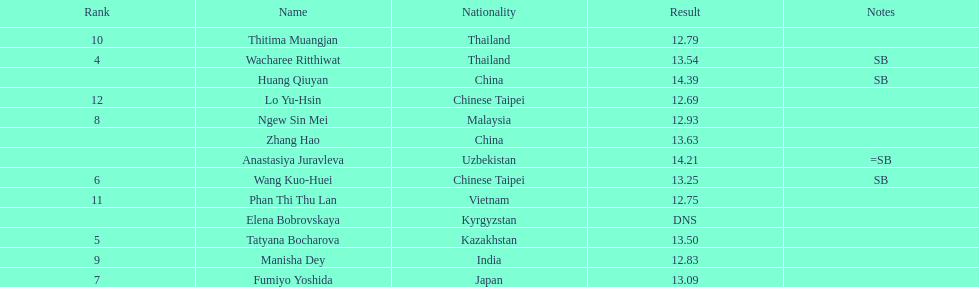What is the number of different nationalities represented by the top 5 athletes? 4. Could you parse the entire table as a dict? {'header': ['Rank', 'Name', 'Nationality', 'Result', 'Notes'], 'rows': [['10', 'Thitima Muangjan', 'Thailand', '12.79', ''], ['4', 'Wacharee Ritthiwat', 'Thailand', '13.54', 'SB'], ['', 'Huang Qiuyan', 'China', '14.39', 'SB'], ['12', 'Lo Yu-Hsin', 'Chinese Taipei', '12.69', ''], ['8', 'Ngew Sin Mei', 'Malaysia', '12.93', ''], ['', 'Zhang Hao', 'China', '13.63', ''], ['', 'Anastasiya Juravleva', 'Uzbekistan', '14.21', '=SB'], ['6', 'Wang Kuo-Huei', 'Chinese Taipei', '13.25', 'SB'], ['11', 'Phan Thi Thu Lan', 'Vietnam', '12.75', ''], ['', 'Elena Bobrovskaya', 'Kyrgyzstan', 'DNS', ''], ['5', 'Tatyana Bocharova', 'Kazakhstan', '13.50', ''], ['9', 'Manisha Dey', 'India', '12.83', ''], ['7', 'Fumiyo Yoshida', 'Japan', '13.09', '']]} 